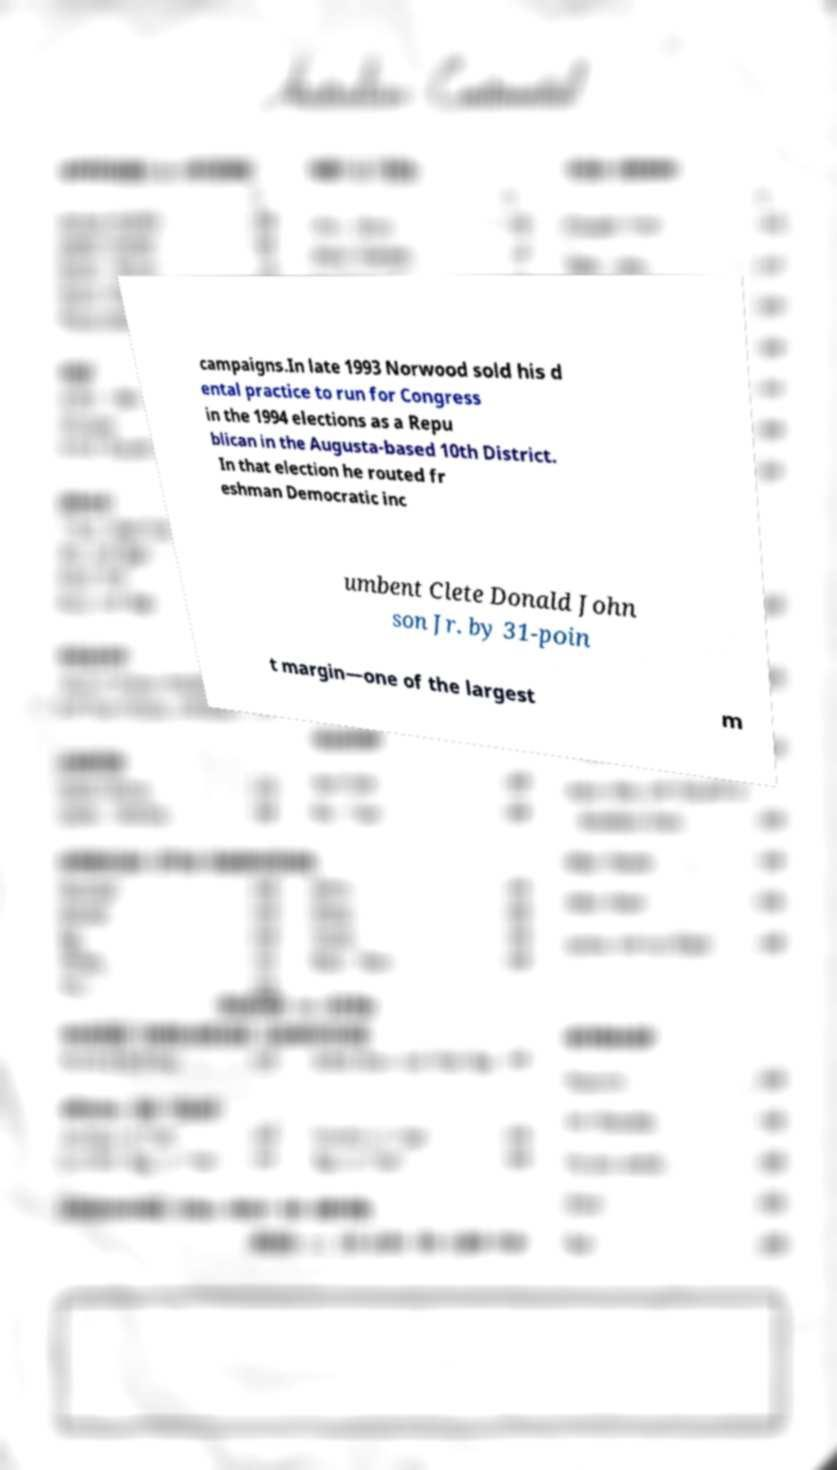What messages or text are displayed in this image? I need them in a readable, typed format. campaigns.In late 1993 Norwood sold his d ental practice to run for Congress in the 1994 elections as a Repu blican in the Augusta-based 10th District. In that election he routed fr eshman Democratic inc umbent Clete Donald John son Jr. by 31-poin t margin—one of the largest m 